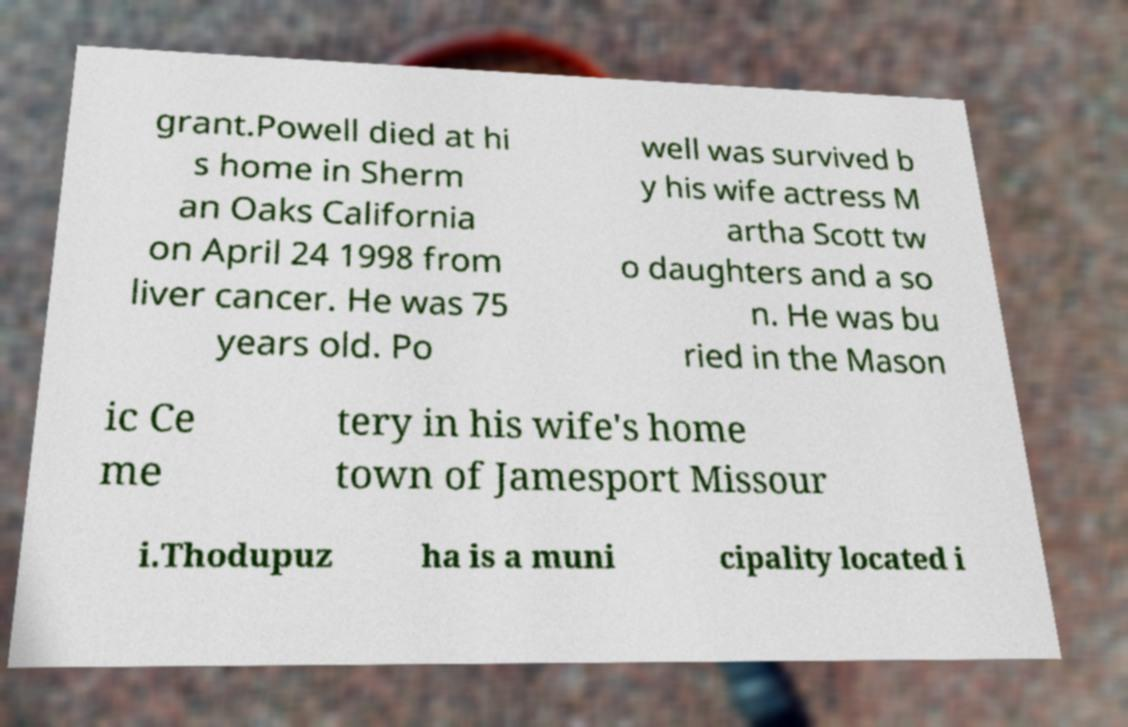I need the written content from this picture converted into text. Can you do that? grant.Powell died at hi s home in Sherm an Oaks California on April 24 1998 from liver cancer. He was 75 years old. Po well was survived b y his wife actress M artha Scott tw o daughters and a so n. He was bu ried in the Mason ic Ce me tery in his wife's home town of Jamesport Missour i.Thodupuz ha is a muni cipality located i 